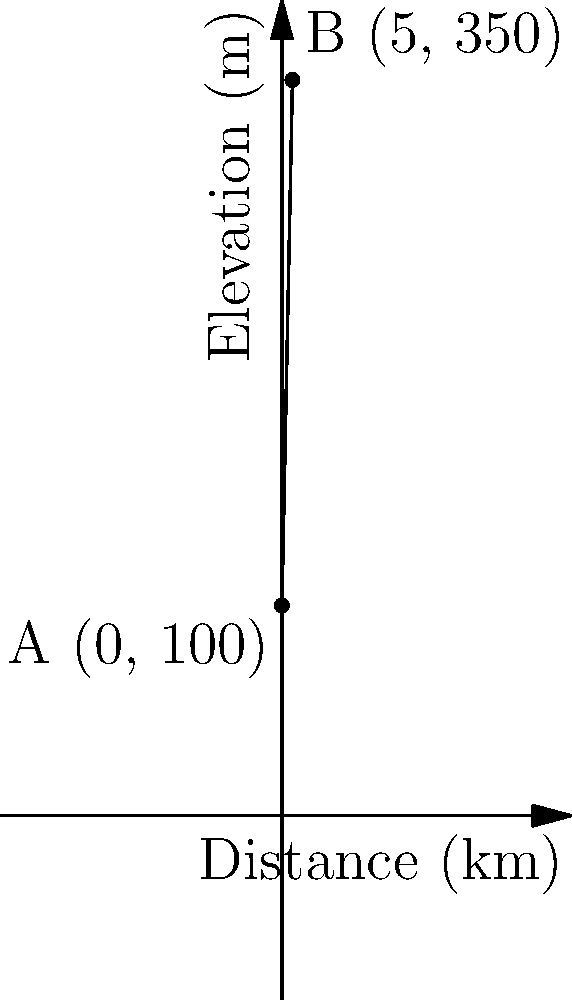As a local news reporter covering outdoor activities in Yavapai County, you're writing a story about hiking trails in Prescott National Forest. A new trail has been mapped using coordinate geometry, with the starting point A at (0, 100) and the endpoint B at (5, 350), where the x-axis represents distance in kilometers and the y-axis represents elevation in meters. What is the slope of this trail, and what is its length to the nearest tenth of a kilometer? To solve this problem, we'll follow these steps:

1. Calculate the slope of the trail:
   The slope formula is $m = \frac{y_2 - y_1}{x_2 - x_1}$
   $m = \frac{350 - 100}{5 - 0} = \frac{250}{5} = 50$

   This means the trail rises 50 meters for every kilometer of horizontal distance.

2. Calculate the length of the trail:
   We can use the distance formula: $d = \sqrt{(x_2 - x_1)^2 + (y_2 - y_1)^2}$
   
   $d = \sqrt{(5 - 0)^2 + (350 - 100)^2}$
   $d = \sqrt{25 + 62500}$
   $d = \sqrt{62525}$
   $d \approx 250.05$

3. Convert the length to kilometers:
   Since the x-axis is in kilometers and the y-axis is in meters, we need to convert the y-difference to kilometers:
   $250.05 \div 1000 = 0.25005$ km

4. Round to the nearest tenth of a kilometer:
   $0.25005$ km rounds to $0.3$ km

Therefore, the slope of the trail is 50 m/km, and its length is approximately 0.3 km.
Answer: Slope: 50 m/km; Length: 0.3 km 